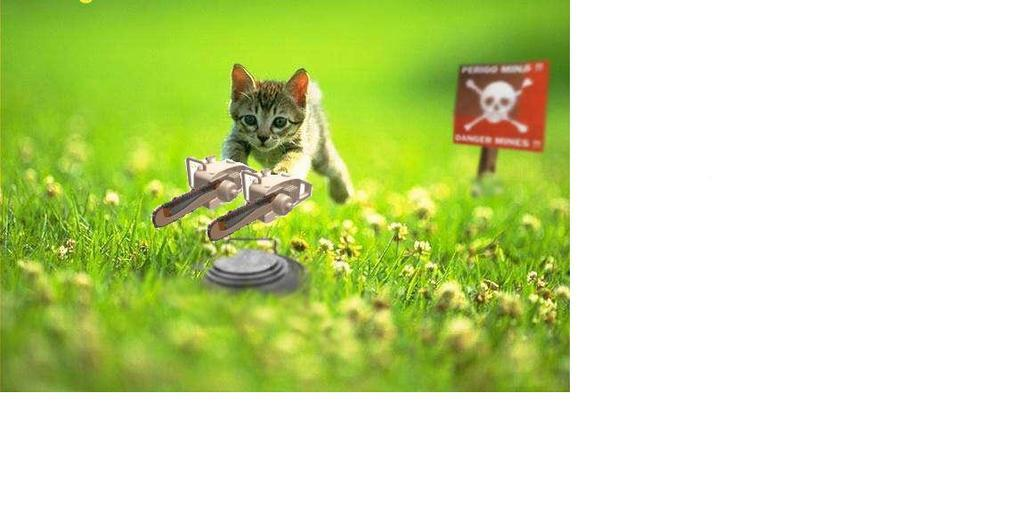What type of vegetation is present in the image? There is green grass in the image. What animal can be seen on the grass? There is a small kitten on the grass. What is the color and purpose of the board on the right side of the image? There is a red color danger board on the right side of the image. How does the kettle affect the grass in the image? There is no kettle present in the image, so it cannot affect the grass. 